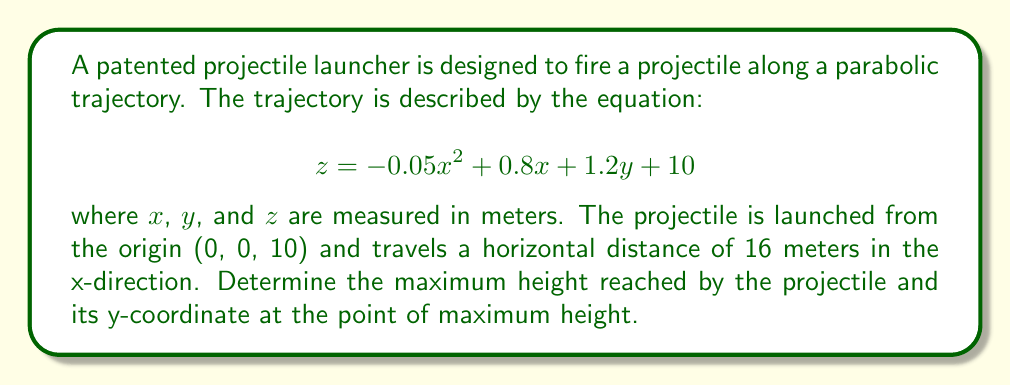Give your solution to this math problem. To solve this problem, we'll follow these steps:

1) First, we need to find the x-coordinate of the highest point. At the highest point, the partial derivative of z with respect to x will be zero:

   $$\frac{\partial z}{\partial x} = -0.1x + 0.8 = 0$$
   $$-0.1x = -0.8$$
   $$x = 8$$

2) Now that we know the x-coordinate of the highest point is 8 meters, we can find the y-coordinate. Since y doesn't affect the height directly (the coefficient of y is constant), the y-coordinate at the highest point will be half of the total y-distance traveled.

   The total x-distance is 16 meters, so the y-distance will also be 16 meters (assuming the projectile travels at a 45-degree angle to the x-axis in the xy-plane).

   Therefore, the y-coordinate at the highest point is:
   $$y = 16 / 2 = 8$$

3) To find the maximum height, we substitute x = 8 and y = 8 into the original equation:

   $$z = -0.05(8)^2 + 0.8(8) + 1.2(8) + 10$$
   $$z = -0.05(64) + 6.4 + 9.6 + 10$$
   $$z = -3.2 + 6.4 + 9.6 + 10$$
   $$z = 22.8$$

Therefore, the maximum height reached by the projectile is 22.8 meters, and it occurs at the point (8, 8, 22.8).
Answer: Maximum height: 22.8 meters
Y-coordinate at maximum height: 8 meters 